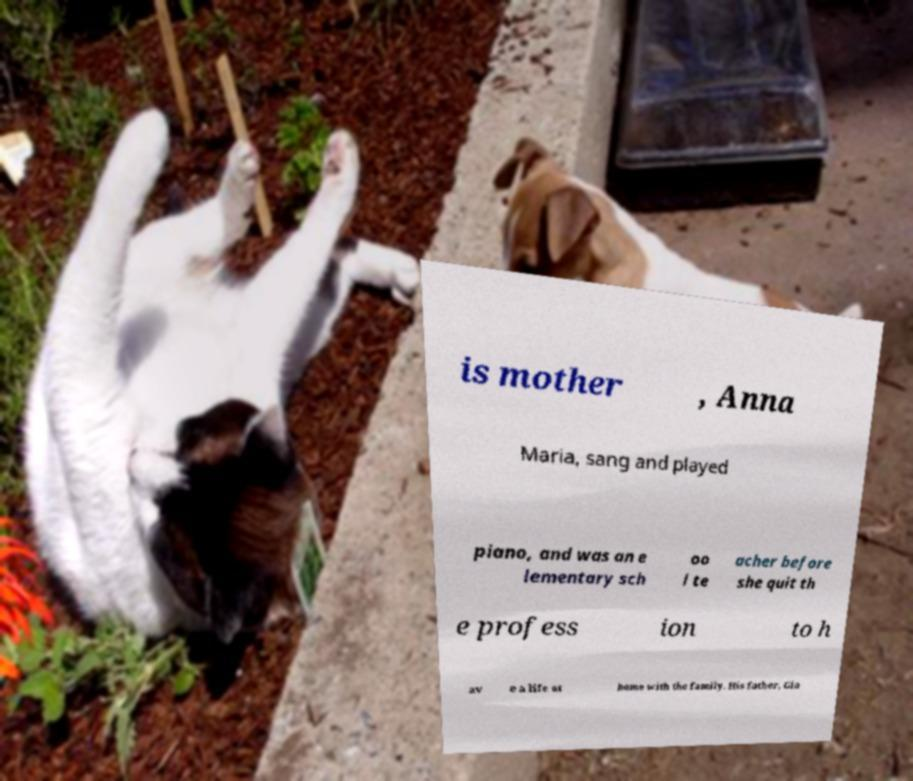For documentation purposes, I need the text within this image transcribed. Could you provide that? is mother , Anna Maria, sang and played piano, and was an e lementary sch oo l te acher before she quit th e profess ion to h av e a life at home with the family. His father, Gia 